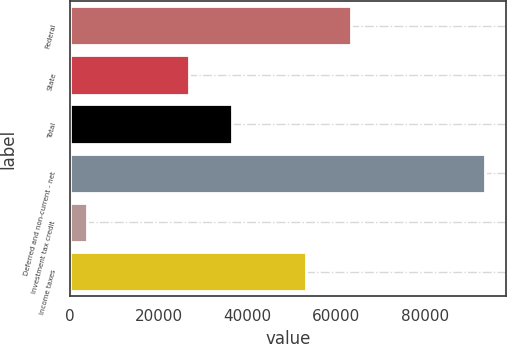<chart> <loc_0><loc_0><loc_500><loc_500><bar_chart><fcel>Federal<fcel>State<fcel>Total<fcel>Deferred and non-current - net<fcel>Investment tax credit<fcel>Income taxes<nl><fcel>63302<fcel>26755<fcel>36547<fcel>93491<fcel>3867<fcel>53077<nl></chart> 